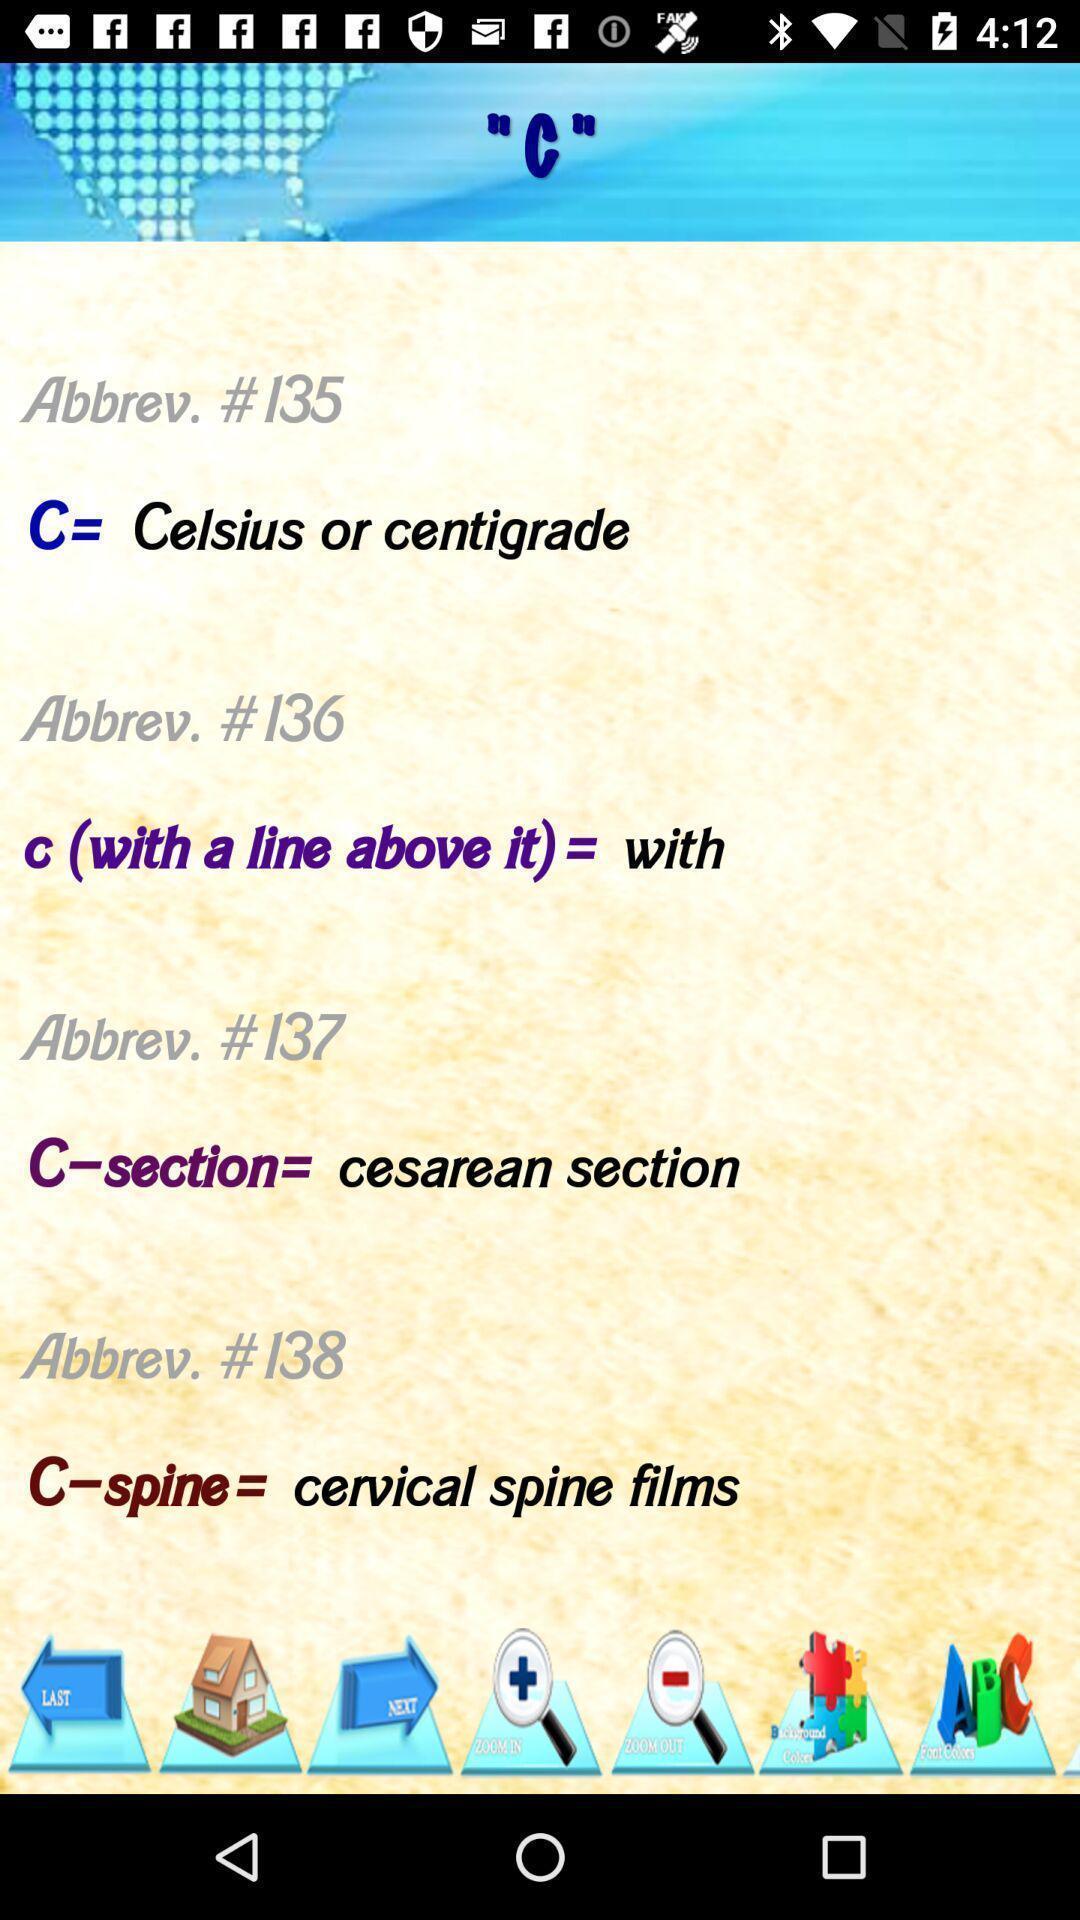Describe the key features of this screenshot. Screen page of a learning application. 